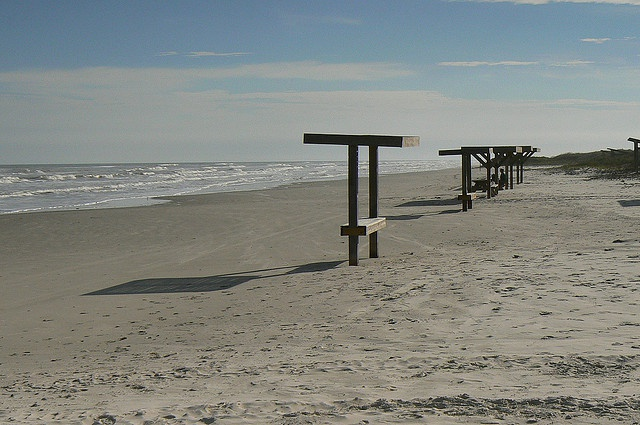Describe the objects in this image and their specific colors. I can see bench in gray, black, and darkgray tones, bench in gray, black, darkgray, and tan tones, people in gray, black, and darkgray tones, people in gray, black, and darkgray tones, and bench in gray, black, and darkgray tones in this image. 